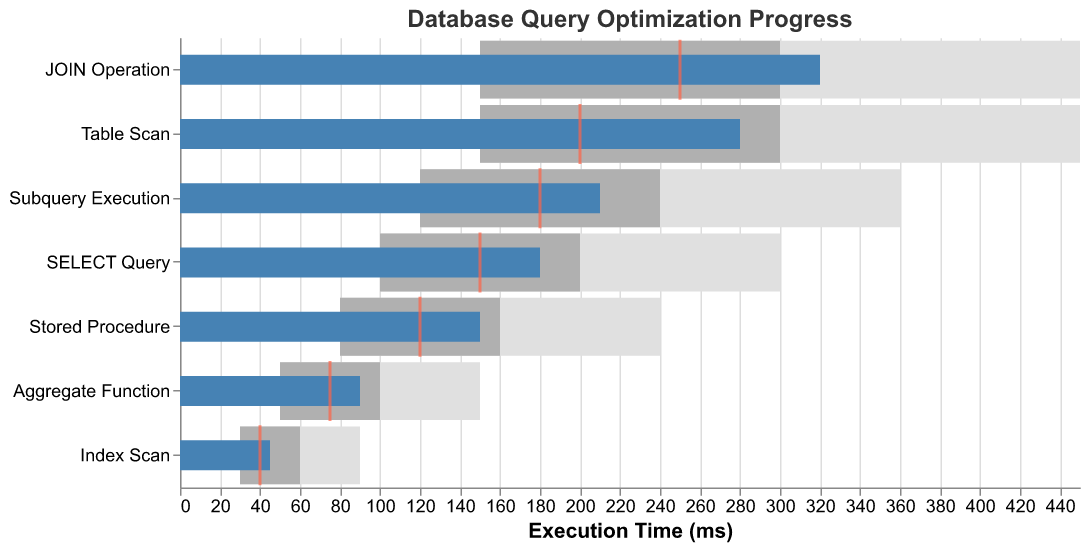What's the title of the chart? The title is located at the top of the chart in a larger font and reads "Database Query Optimization Progress".
Answer: Database Query Optimization Progress What is the actual execution time for the "SELECT Query" category? Find the bar labeled "SELECT Query" and look for the "Actual" execution time in darker color. It represents the current execution time, which is 180 ms.
Answer: 180 ms How does the actual execution time for "JOIN Operation" compare to its target time? Check the "JOIN Operation" bar for the darker colored actual time and the small tick for the target time. The actual time is 320 ms, and the target time is 250 ms.
Answer: The actual time is 70 ms higher than the target time Which category has the smallest difference between actual and target execution times? Compare each category's actual and target values by calculating their differences: SELECT Query (180-150=30), JOIN Operation (320-250=70), Aggregate Function (90-75=15), Subquery Execution (210-180=30), Index Scan (45-40=5), Table Scan (280-200=80), Stored Procedure (150-120=30). The smallest difference is for Index Scan with a difference of 5 ms.
Answer: Index Scan Which category has the highest actual execution time? Look at the lengths of the darkest bars representing the actual times and compare them. The "JOIN Operation" has the longest bar and thus the highest actual execution time at 320 ms.
Answer: JOIN Operation How many categories have an actual execution time exceeding their target time? Count the categories where the actual execution bar exceeds the small tick representing the target time. These are SELECT Query (180>150), JOIN Operation (320>250), Subquery Execution (210>180), Table Scan (280>200), and Stored Procedure (150>120), results in five categories.
Answer: 5 What's the difference between the actual and target times for the category "Subquery Execution"? Find the actual time and target time for "Subquery Execution." The actual time is 210 ms, and the target time is 180 ms. Subtract the target from the actual: 210 - 180 = 30 ms.
Answer: 30 ms What is the target execution time for the category with the lowest actual execution time? Locate the category with the shortest darker bar which is "Index Scan" with an actual time of 45 ms. The target time for "Index Scan" is indicated by a tick mark at 40 ms.
Answer: 40 ms For which category does the range for "Range2" end below its respective actual execution time? Compare each category's actual execution time with the end of their "Range2" (lighter gray bar). The categories are: SELECT Query (200 < 180), JOIN Operation (300 > 320), Aggregate Function (100 > 90), Subquery Execution (240 > 210), Index Scan (60 > 45), Table Scan (300 < 280), and Stored Procedure (160 > 150). Only "JOIN Operation" has its "Range2" ending (300 ms) below the actual execution time (320 ms).
Answer: JOIN Operation 